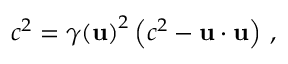<formula> <loc_0><loc_0><loc_500><loc_500>c ^ { 2 } = { \gamma ( u ) } ^ { 2 } \left ( c ^ { 2 } - u \cdot u \right ) \, ,</formula> 